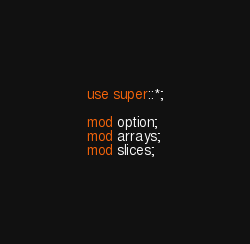Convert code to text. <code><loc_0><loc_0><loc_500><loc_500><_Rust_>use super::*;

mod option;
mod arrays;
mod slices;
</code> 